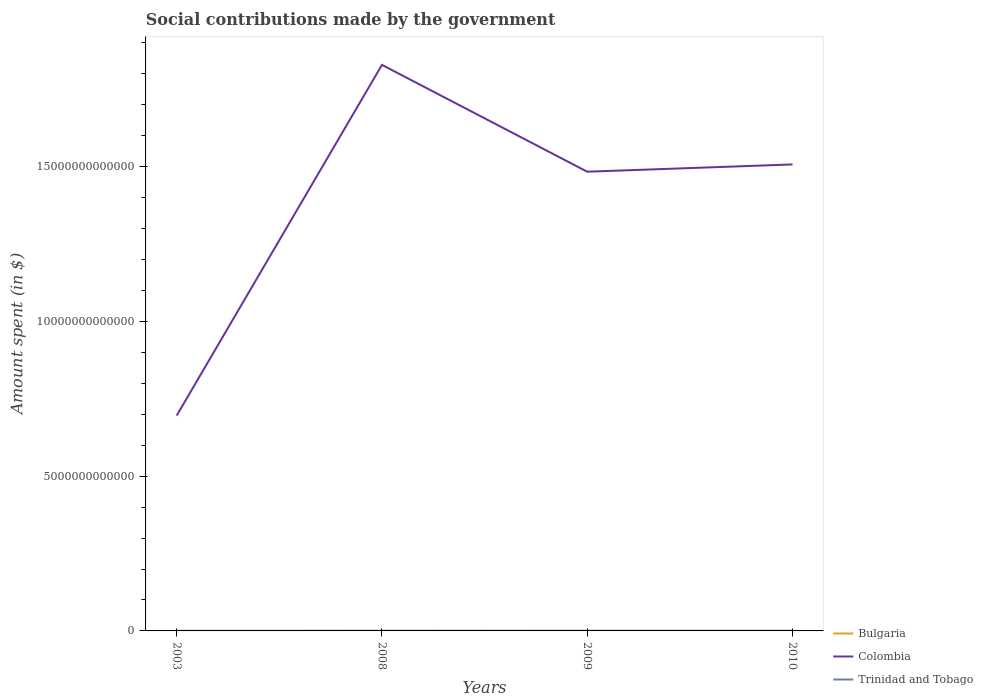Does the line corresponding to Trinidad and Tobago intersect with the line corresponding to Colombia?
Your answer should be very brief. No. Is the number of lines equal to the number of legend labels?
Provide a short and direct response. Yes. Across all years, what is the maximum amount spent on social contributions in Colombia?
Your answer should be compact. 6.96e+12. What is the total amount spent on social contributions in Trinidad and Tobago in the graph?
Your response must be concise. -9.38e+07. What is the difference between the highest and the second highest amount spent on social contributions in Bulgaria?
Make the answer very short. 1.74e+09. Is the amount spent on social contributions in Bulgaria strictly greater than the amount spent on social contributions in Colombia over the years?
Keep it short and to the point. Yes. How many lines are there?
Make the answer very short. 3. What is the difference between two consecutive major ticks on the Y-axis?
Ensure brevity in your answer.  5.00e+12. Does the graph contain any zero values?
Your answer should be very brief. No. Where does the legend appear in the graph?
Offer a terse response. Bottom right. How are the legend labels stacked?
Your response must be concise. Vertical. What is the title of the graph?
Your response must be concise. Social contributions made by the government. Does "Small states" appear as one of the legend labels in the graph?
Make the answer very short. No. What is the label or title of the X-axis?
Provide a short and direct response. Years. What is the label or title of the Y-axis?
Provide a succinct answer. Amount spent (in $). What is the Amount spent (in $) of Bulgaria in 2003?
Your response must be concise. 3.65e+09. What is the Amount spent (in $) of Colombia in 2003?
Make the answer very short. 6.96e+12. What is the Amount spent (in $) in Trinidad and Tobago in 2003?
Offer a terse response. 9.06e+08. What is the Amount spent (in $) of Bulgaria in 2008?
Provide a short and direct response. 5.39e+09. What is the Amount spent (in $) of Colombia in 2008?
Provide a succinct answer. 1.83e+13. What is the Amount spent (in $) in Trinidad and Tobago in 2008?
Make the answer very short. 2.21e+09. What is the Amount spent (in $) of Bulgaria in 2009?
Your answer should be compact. 5.27e+09. What is the Amount spent (in $) of Colombia in 2009?
Your answer should be compact. 1.48e+13. What is the Amount spent (in $) in Trinidad and Tobago in 2009?
Provide a short and direct response. 2.61e+09. What is the Amount spent (in $) of Bulgaria in 2010?
Offer a very short reply. 4.97e+09. What is the Amount spent (in $) in Colombia in 2010?
Keep it short and to the point. 1.51e+13. What is the Amount spent (in $) of Trinidad and Tobago in 2010?
Give a very brief answer. 2.70e+09. Across all years, what is the maximum Amount spent (in $) of Bulgaria?
Provide a short and direct response. 5.39e+09. Across all years, what is the maximum Amount spent (in $) in Colombia?
Your answer should be very brief. 1.83e+13. Across all years, what is the maximum Amount spent (in $) of Trinidad and Tobago?
Give a very brief answer. 2.70e+09. Across all years, what is the minimum Amount spent (in $) of Bulgaria?
Offer a very short reply. 3.65e+09. Across all years, what is the minimum Amount spent (in $) of Colombia?
Make the answer very short. 6.96e+12. Across all years, what is the minimum Amount spent (in $) of Trinidad and Tobago?
Make the answer very short. 9.06e+08. What is the total Amount spent (in $) in Bulgaria in the graph?
Provide a short and direct response. 1.93e+1. What is the total Amount spent (in $) of Colombia in the graph?
Make the answer very short. 5.51e+13. What is the total Amount spent (in $) of Trinidad and Tobago in the graph?
Make the answer very short. 8.42e+09. What is the difference between the Amount spent (in $) in Bulgaria in 2003 and that in 2008?
Your answer should be compact. -1.74e+09. What is the difference between the Amount spent (in $) of Colombia in 2003 and that in 2008?
Provide a succinct answer. -1.13e+13. What is the difference between the Amount spent (in $) in Trinidad and Tobago in 2003 and that in 2008?
Offer a terse response. -1.30e+09. What is the difference between the Amount spent (in $) of Bulgaria in 2003 and that in 2009?
Provide a short and direct response. -1.62e+09. What is the difference between the Amount spent (in $) in Colombia in 2003 and that in 2009?
Provide a succinct answer. -7.88e+12. What is the difference between the Amount spent (in $) in Trinidad and Tobago in 2003 and that in 2009?
Your answer should be compact. -1.70e+09. What is the difference between the Amount spent (in $) of Bulgaria in 2003 and that in 2010?
Give a very brief answer. -1.32e+09. What is the difference between the Amount spent (in $) of Colombia in 2003 and that in 2010?
Provide a succinct answer. -8.11e+12. What is the difference between the Amount spent (in $) in Trinidad and Tobago in 2003 and that in 2010?
Provide a short and direct response. -1.80e+09. What is the difference between the Amount spent (in $) of Bulgaria in 2008 and that in 2009?
Your response must be concise. 1.20e+08. What is the difference between the Amount spent (in $) of Colombia in 2008 and that in 2009?
Give a very brief answer. 3.45e+12. What is the difference between the Amount spent (in $) in Trinidad and Tobago in 2008 and that in 2009?
Provide a succinct answer. -4.01e+08. What is the difference between the Amount spent (in $) of Bulgaria in 2008 and that in 2010?
Your answer should be compact. 4.23e+08. What is the difference between the Amount spent (in $) of Colombia in 2008 and that in 2010?
Provide a short and direct response. 3.22e+12. What is the difference between the Amount spent (in $) in Trinidad and Tobago in 2008 and that in 2010?
Your response must be concise. -4.95e+08. What is the difference between the Amount spent (in $) in Bulgaria in 2009 and that in 2010?
Provide a succinct answer. 3.03e+08. What is the difference between the Amount spent (in $) of Colombia in 2009 and that in 2010?
Provide a short and direct response. -2.35e+11. What is the difference between the Amount spent (in $) in Trinidad and Tobago in 2009 and that in 2010?
Make the answer very short. -9.38e+07. What is the difference between the Amount spent (in $) of Bulgaria in 2003 and the Amount spent (in $) of Colombia in 2008?
Offer a very short reply. -1.83e+13. What is the difference between the Amount spent (in $) in Bulgaria in 2003 and the Amount spent (in $) in Trinidad and Tobago in 2008?
Offer a very short reply. 1.45e+09. What is the difference between the Amount spent (in $) in Colombia in 2003 and the Amount spent (in $) in Trinidad and Tobago in 2008?
Your answer should be compact. 6.95e+12. What is the difference between the Amount spent (in $) in Bulgaria in 2003 and the Amount spent (in $) in Colombia in 2009?
Ensure brevity in your answer.  -1.48e+13. What is the difference between the Amount spent (in $) of Bulgaria in 2003 and the Amount spent (in $) of Trinidad and Tobago in 2009?
Give a very brief answer. 1.05e+09. What is the difference between the Amount spent (in $) of Colombia in 2003 and the Amount spent (in $) of Trinidad and Tobago in 2009?
Your response must be concise. 6.95e+12. What is the difference between the Amount spent (in $) of Bulgaria in 2003 and the Amount spent (in $) of Colombia in 2010?
Your response must be concise. -1.51e+13. What is the difference between the Amount spent (in $) of Bulgaria in 2003 and the Amount spent (in $) of Trinidad and Tobago in 2010?
Offer a terse response. 9.51e+08. What is the difference between the Amount spent (in $) of Colombia in 2003 and the Amount spent (in $) of Trinidad and Tobago in 2010?
Provide a short and direct response. 6.95e+12. What is the difference between the Amount spent (in $) of Bulgaria in 2008 and the Amount spent (in $) of Colombia in 2009?
Make the answer very short. -1.48e+13. What is the difference between the Amount spent (in $) in Bulgaria in 2008 and the Amount spent (in $) in Trinidad and Tobago in 2009?
Your response must be concise. 2.78e+09. What is the difference between the Amount spent (in $) in Colombia in 2008 and the Amount spent (in $) in Trinidad and Tobago in 2009?
Your response must be concise. 1.83e+13. What is the difference between the Amount spent (in $) in Bulgaria in 2008 and the Amount spent (in $) in Colombia in 2010?
Keep it short and to the point. -1.51e+13. What is the difference between the Amount spent (in $) in Bulgaria in 2008 and the Amount spent (in $) in Trinidad and Tobago in 2010?
Your response must be concise. 2.69e+09. What is the difference between the Amount spent (in $) of Colombia in 2008 and the Amount spent (in $) of Trinidad and Tobago in 2010?
Provide a short and direct response. 1.83e+13. What is the difference between the Amount spent (in $) in Bulgaria in 2009 and the Amount spent (in $) in Colombia in 2010?
Offer a terse response. -1.51e+13. What is the difference between the Amount spent (in $) in Bulgaria in 2009 and the Amount spent (in $) in Trinidad and Tobago in 2010?
Your answer should be compact. 2.57e+09. What is the difference between the Amount spent (in $) of Colombia in 2009 and the Amount spent (in $) of Trinidad and Tobago in 2010?
Your answer should be very brief. 1.48e+13. What is the average Amount spent (in $) in Bulgaria per year?
Give a very brief answer. 4.82e+09. What is the average Amount spent (in $) of Colombia per year?
Provide a short and direct response. 1.38e+13. What is the average Amount spent (in $) of Trinidad and Tobago per year?
Provide a succinct answer. 2.11e+09. In the year 2003, what is the difference between the Amount spent (in $) of Bulgaria and Amount spent (in $) of Colombia?
Your response must be concise. -6.95e+12. In the year 2003, what is the difference between the Amount spent (in $) of Bulgaria and Amount spent (in $) of Trinidad and Tobago?
Provide a succinct answer. 2.75e+09. In the year 2003, what is the difference between the Amount spent (in $) of Colombia and Amount spent (in $) of Trinidad and Tobago?
Make the answer very short. 6.96e+12. In the year 2008, what is the difference between the Amount spent (in $) in Bulgaria and Amount spent (in $) in Colombia?
Your response must be concise. -1.83e+13. In the year 2008, what is the difference between the Amount spent (in $) of Bulgaria and Amount spent (in $) of Trinidad and Tobago?
Ensure brevity in your answer.  3.19e+09. In the year 2008, what is the difference between the Amount spent (in $) in Colombia and Amount spent (in $) in Trinidad and Tobago?
Your answer should be very brief. 1.83e+13. In the year 2009, what is the difference between the Amount spent (in $) in Bulgaria and Amount spent (in $) in Colombia?
Offer a very short reply. -1.48e+13. In the year 2009, what is the difference between the Amount spent (in $) of Bulgaria and Amount spent (in $) of Trinidad and Tobago?
Make the answer very short. 2.66e+09. In the year 2009, what is the difference between the Amount spent (in $) in Colombia and Amount spent (in $) in Trinidad and Tobago?
Keep it short and to the point. 1.48e+13. In the year 2010, what is the difference between the Amount spent (in $) of Bulgaria and Amount spent (in $) of Colombia?
Your response must be concise. -1.51e+13. In the year 2010, what is the difference between the Amount spent (in $) of Bulgaria and Amount spent (in $) of Trinidad and Tobago?
Ensure brevity in your answer.  2.27e+09. In the year 2010, what is the difference between the Amount spent (in $) of Colombia and Amount spent (in $) of Trinidad and Tobago?
Your answer should be very brief. 1.51e+13. What is the ratio of the Amount spent (in $) of Bulgaria in 2003 to that in 2008?
Give a very brief answer. 0.68. What is the ratio of the Amount spent (in $) in Colombia in 2003 to that in 2008?
Ensure brevity in your answer.  0.38. What is the ratio of the Amount spent (in $) in Trinidad and Tobago in 2003 to that in 2008?
Your response must be concise. 0.41. What is the ratio of the Amount spent (in $) in Bulgaria in 2003 to that in 2009?
Keep it short and to the point. 0.69. What is the ratio of the Amount spent (in $) of Colombia in 2003 to that in 2009?
Ensure brevity in your answer.  0.47. What is the ratio of the Amount spent (in $) in Trinidad and Tobago in 2003 to that in 2009?
Offer a terse response. 0.35. What is the ratio of the Amount spent (in $) of Bulgaria in 2003 to that in 2010?
Your answer should be compact. 0.74. What is the ratio of the Amount spent (in $) of Colombia in 2003 to that in 2010?
Your answer should be compact. 0.46. What is the ratio of the Amount spent (in $) of Trinidad and Tobago in 2003 to that in 2010?
Provide a short and direct response. 0.34. What is the ratio of the Amount spent (in $) of Bulgaria in 2008 to that in 2009?
Give a very brief answer. 1.02. What is the ratio of the Amount spent (in $) in Colombia in 2008 to that in 2009?
Provide a short and direct response. 1.23. What is the ratio of the Amount spent (in $) in Trinidad and Tobago in 2008 to that in 2009?
Your response must be concise. 0.85. What is the ratio of the Amount spent (in $) in Bulgaria in 2008 to that in 2010?
Give a very brief answer. 1.09. What is the ratio of the Amount spent (in $) of Colombia in 2008 to that in 2010?
Offer a very short reply. 1.21. What is the ratio of the Amount spent (in $) of Trinidad and Tobago in 2008 to that in 2010?
Make the answer very short. 0.82. What is the ratio of the Amount spent (in $) of Bulgaria in 2009 to that in 2010?
Give a very brief answer. 1.06. What is the ratio of the Amount spent (in $) in Colombia in 2009 to that in 2010?
Offer a terse response. 0.98. What is the ratio of the Amount spent (in $) in Trinidad and Tobago in 2009 to that in 2010?
Offer a terse response. 0.97. What is the difference between the highest and the second highest Amount spent (in $) of Bulgaria?
Offer a terse response. 1.20e+08. What is the difference between the highest and the second highest Amount spent (in $) in Colombia?
Offer a terse response. 3.22e+12. What is the difference between the highest and the second highest Amount spent (in $) in Trinidad and Tobago?
Offer a very short reply. 9.38e+07. What is the difference between the highest and the lowest Amount spent (in $) of Bulgaria?
Your response must be concise. 1.74e+09. What is the difference between the highest and the lowest Amount spent (in $) of Colombia?
Your answer should be compact. 1.13e+13. What is the difference between the highest and the lowest Amount spent (in $) in Trinidad and Tobago?
Provide a succinct answer. 1.80e+09. 